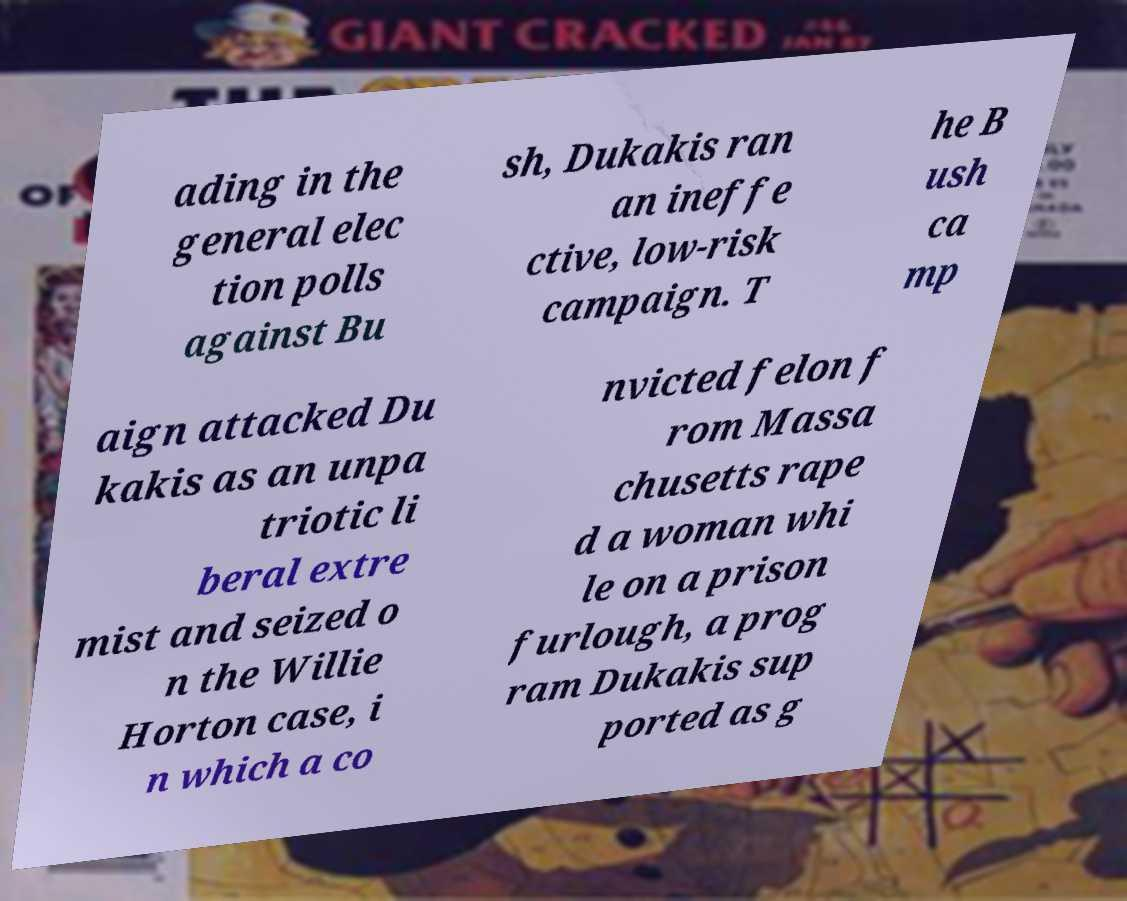What messages or text are displayed in this image? I need them in a readable, typed format. ading in the general elec tion polls against Bu sh, Dukakis ran an ineffe ctive, low-risk campaign. T he B ush ca mp aign attacked Du kakis as an unpa triotic li beral extre mist and seized o n the Willie Horton case, i n which a co nvicted felon f rom Massa chusetts rape d a woman whi le on a prison furlough, a prog ram Dukakis sup ported as g 